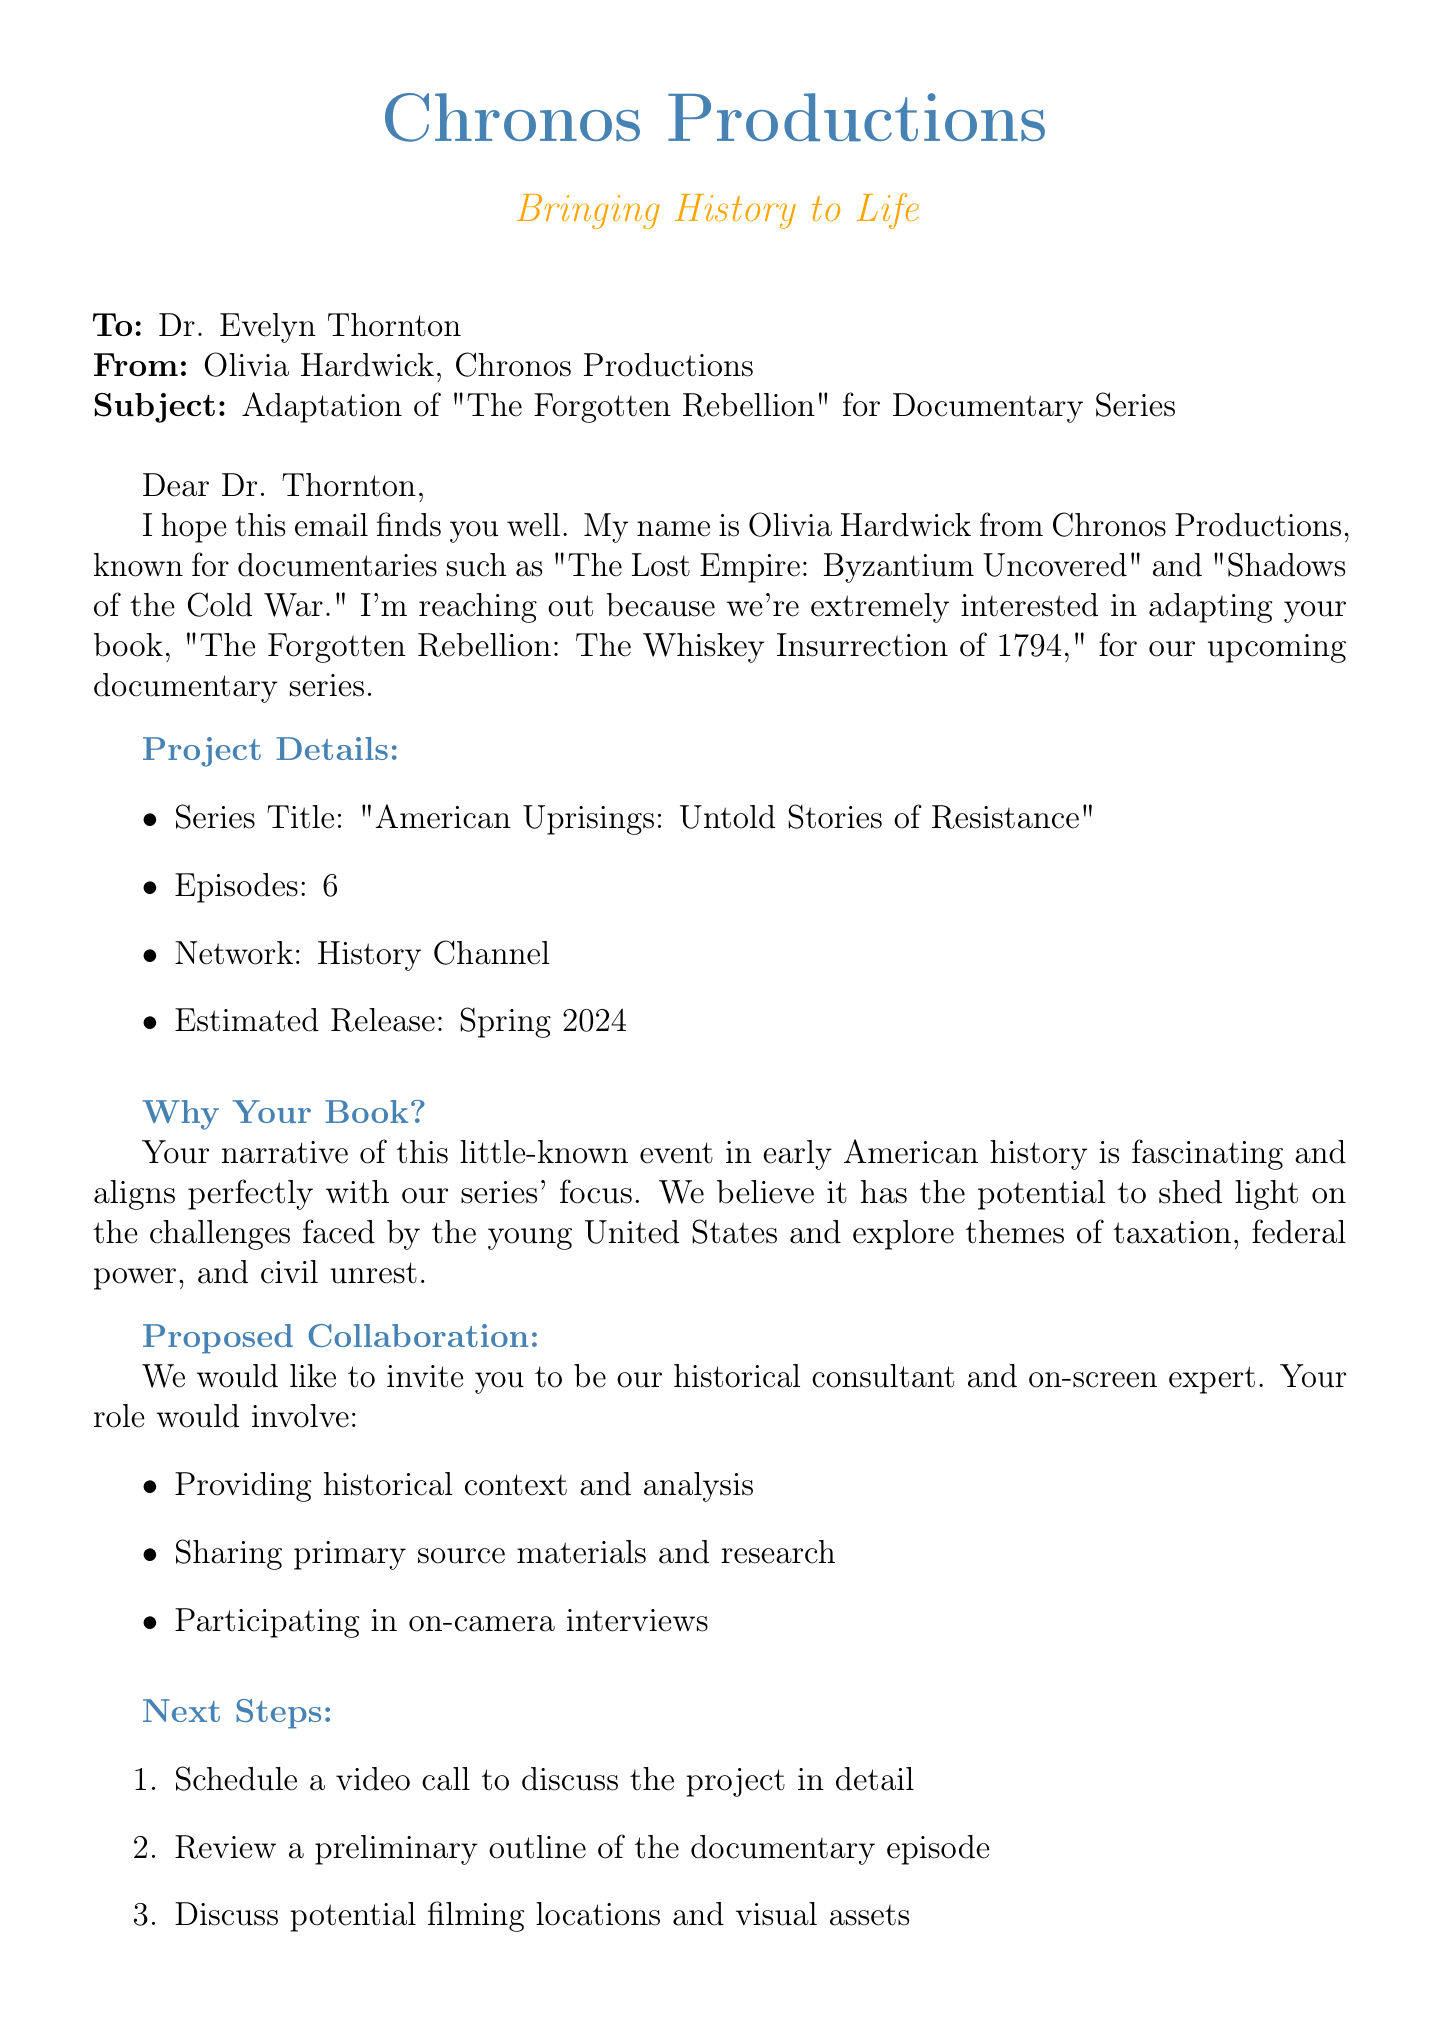What is the name of the filmmaker? The email mentions Olivia Hardwick as the filmmaker reaching out.
Answer: Olivia Hardwick What is the title of the book being adapted? The book's title is specified in the email as the work of Dr. Thornton.
Answer: The Forgotten Rebellion: The Whiskey Insurrection of 1794 How many episodes will the documentary series have? The email states that the documentary series will consist of 6 episodes.
Answer: 6 What network will air the documentary series? The network for the documentary series is specified in the email.
Answer: History Channel What is the proposed start month for production? The email mentions the plan to start production in September 2023.
Answer: September 2023 What role is Dr. Thornton proposed to have in the documentary? The email invites Dr. Thornton to serve as a specific type of consultant and expert.
Answer: Historical consultant and on-screen expert What themes does the documentary series aim to explore? The email lists themes that align with Dr. Thornton's book and the documentary series’ focus.
Answer: Taxation, federal power, and civil unrest What is the estimated release season for the documentary? The email outlines the estimated release timing in the form of a season.
Answer: Spring 2024 